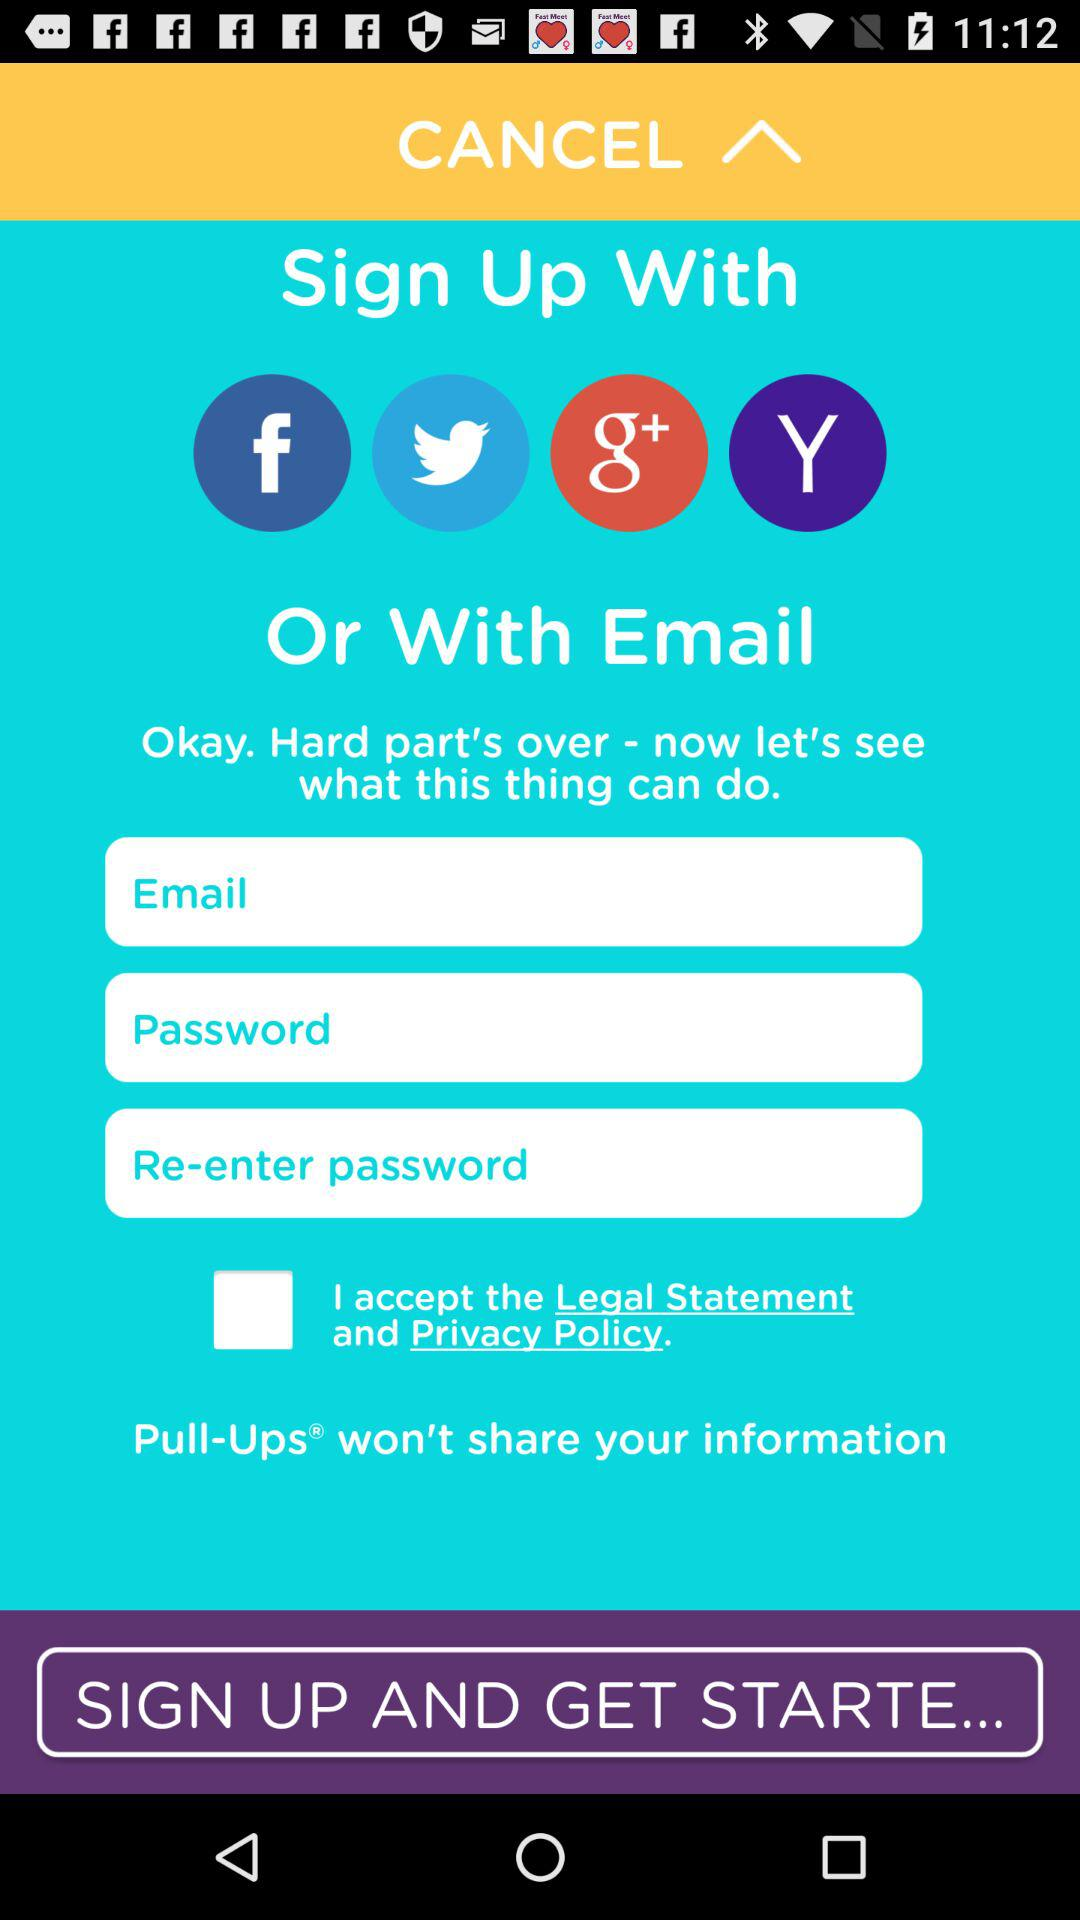What applications can be used to log in to the profile? The applications that can be used to log in to the profile are "Facebook", "Twitter", "Google+" and "Yahoo". 